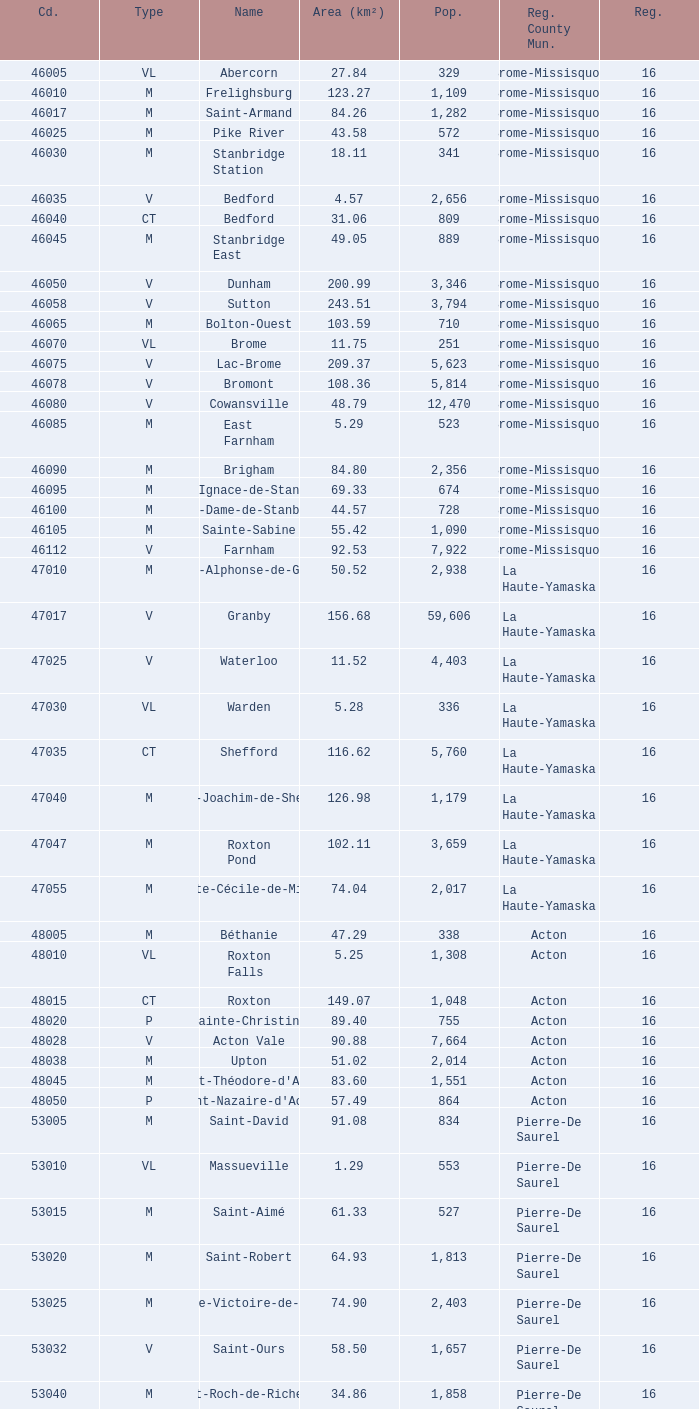Cowansville has less than 16 regions and is a Brome-Missisquoi Municipality, what is their population? None. 